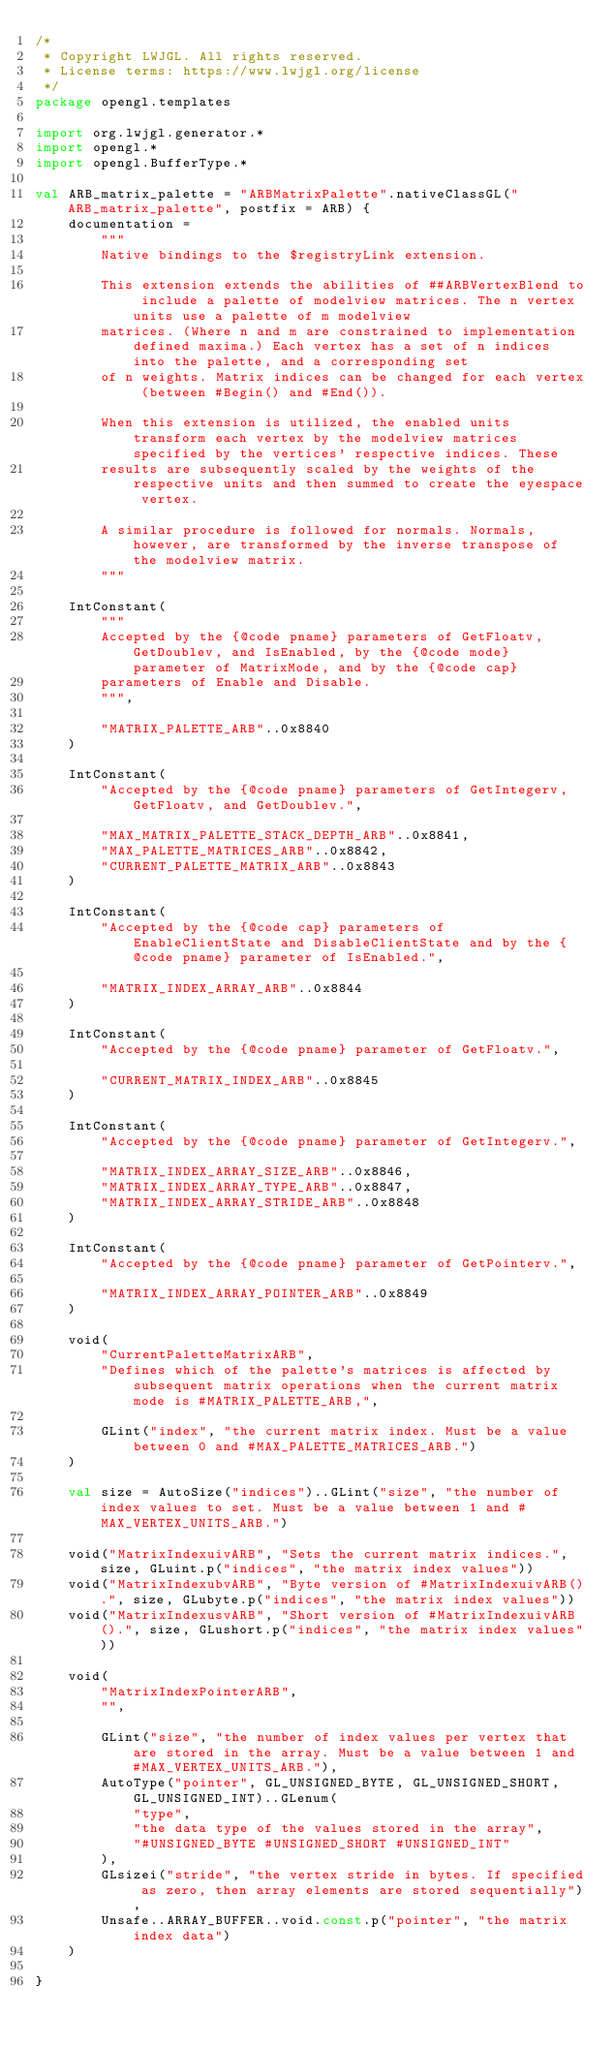<code> <loc_0><loc_0><loc_500><loc_500><_Kotlin_>/*
 * Copyright LWJGL. All rights reserved.
 * License terms: https://www.lwjgl.org/license
 */
package opengl.templates

import org.lwjgl.generator.*
import opengl.*
import opengl.BufferType.*

val ARB_matrix_palette = "ARBMatrixPalette".nativeClassGL("ARB_matrix_palette", postfix = ARB) {
    documentation =
        """
        Native bindings to the $registryLink extension.

        This extension extends the abilities of ##ARBVertexBlend to include a palette of modelview matrices. The n vertex units use a palette of m modelview
        matrices. (Where n and m are constrained to implementation defined maxima.) Each vertex has a set of n indices into the palette, and a corresponding set
        of n weights. Matrix indices can be changed for each vertex (between #Begin() and #End()).

        When this extension is utilized, the enabled units transform each vertex by the modelview matrices specified by the vertices' respective indices. These
        results are subsequently scaled by the weights of the respective units and then summed to create the eyespace vertex.

        A similar procedure is followed for normals. Normals, however, are transformed by the inverse transpose of the modelview matrix.
        """

    IntConstant(
        """
        Accepted by the {@code pname} parameters of GetFloatv, GetDoublev, and IsEnabled, by the {@code mode} parameter of MatrixMode, and by the {@code cap}
        parameters of Enable and Disable.
        """,

        "MATRIX_PALETTE_ARB"..0x8840
    )

    IntConstant(
        "Accepted by the {@code pname} parameters of GetIntegerv, GetFloatv, and GetDoublev.",

        "MAX_MATRIX_PALETTE_STACK_DEPTH_ARB"..0x8841,
        "MAX_PALETTE_MATRICES_ARB"..0x8842,
        "CURRENT_PALETTE_MATRIX_ARB"..0x8843
    )

    IntConstant(
        "Accepted by the {@code cap} parameters of EnableClientState and DisableClientState and by the {@code pname} parameter of IsEnabled.",

        "MATRIX_INDEX_ARRAY_ARB"..0x8844
    )

    IntConstant(
        "Accepted by the {@code pname} parameter of GetFloatv.",

        "CURRENT_MATRIX_INDEX_ARB"..0x8845
    )

    IntConstant(
        "Accepted by the {@code pname} parameter of GetIntegerv.",

        "MATRIX_INDEX_ARRAY_SIZE_ARB"..0x8846,
        "MATRIX_INDEX_ARRAY_TYPE_ARB"..0x8847,
        "MATRIX_INDEX_ARRAY_STRIDE_ARB"..0x8848
    )

    IntConstant(
        "Accepted by the {@code pname} parameter of GetPointerv.",

        "MATRIX_INDEX_ARRAY_POINTER_ARB"..0x8849
    )

    void(
        "CurrentPaletteMatrixARB",
        "Defines which of the palette's matrices is affected by subsequent matrix operations when the current matrix mode is #MATRIX_PALETTE_ARB,",

        GLint("index", "the current matrix index. Must be a value between 0 and #MAX_PALETTE_MATRICES_ARB.")
    )

    val size = AutoSize("indices")..GLint("size", "the number of index values to set. Must be a value between 1 and #MAX_VERTEX_UNITS_ARB.")

    void("MatrixIndexuivARB", "Sets the current matrix indices.", size, GLuint.p("indices", "the matrix index values"))
    void("MatrixIndexubvARB", "Byte version of #MatrixIndexuivARB().", size, GLubyte.p("indices", "the matrix index values"))
    void("MatrixIndexusvARB", "Short version of #MatrixIndexuivARB().", size, GLushort.p("indices", "the matrix index values"))

    void(
        "MatrixIndexPointerARB",
        "",

        GLint("size", "the number of index values per vertex that are stored in the array. Must be a value between 1 and #MAX_VERTEX_UNITS_ARB."),
        AutoType("pointer", GL_UNSIGNED_BYTE, GL_UNSIGNED_SHORT, GL_UNSIGNED_INT)..GLenum(
            "type",
            "the data type of the values stored in the array",
            "#UNSIGNED_BYTE #UNSIGNED_SHORT #UNSIGNED_INT"
        ),
        GLsizei("stride", "the vertex stride in bytes. If specified as zero, then array elements are stored sequentially"),
        Unsafe..ARRAY_BUFFER..void.const.p("pointer", "the matrix index data")
    )

}</code> 